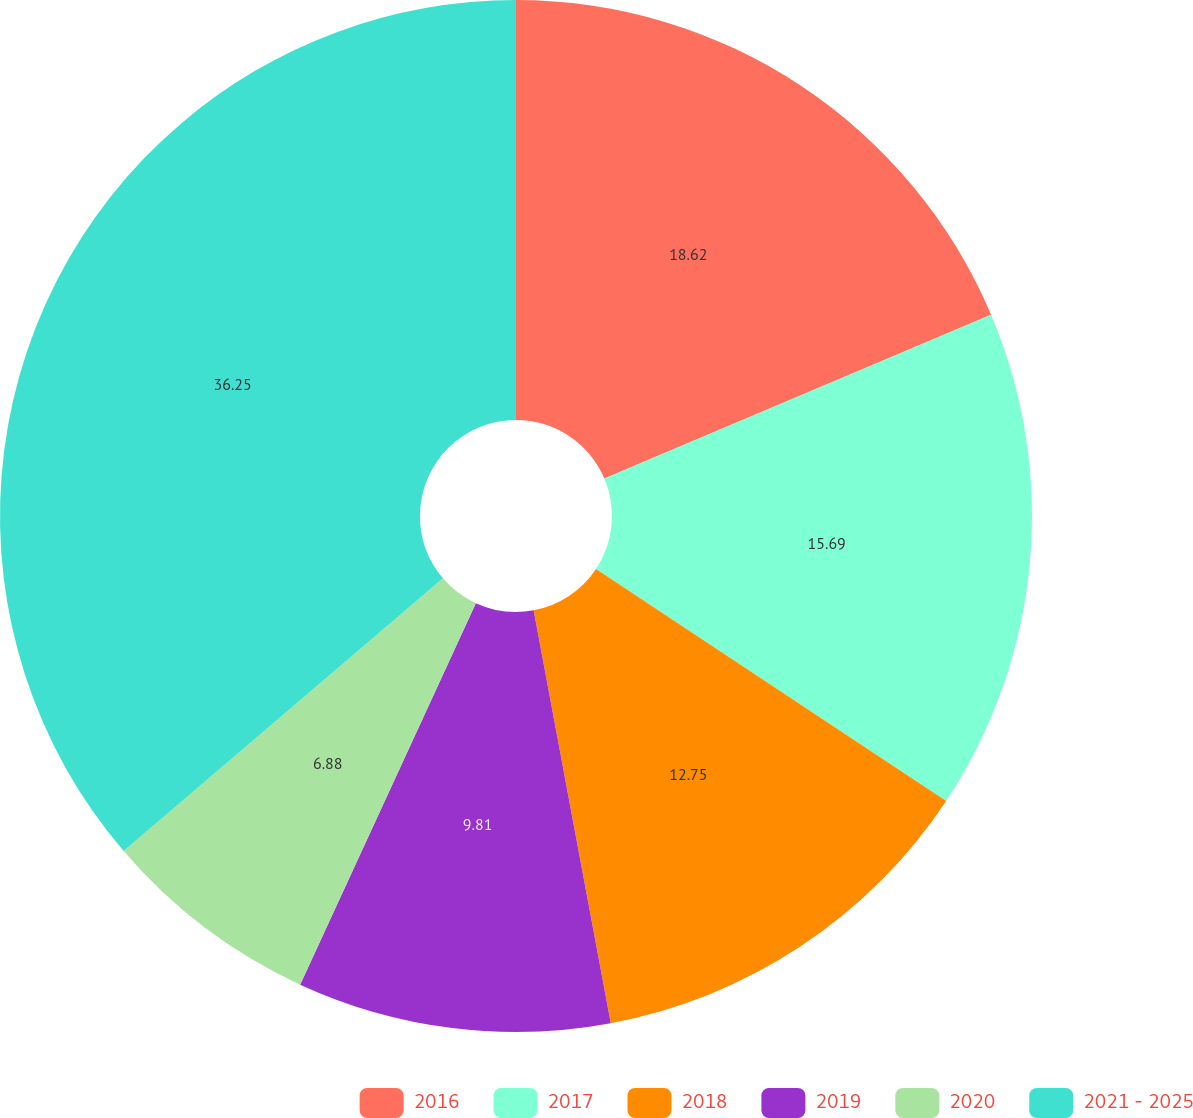Convert chart to OTSL. <chart><loc_0><loc_0><loc_500><loc_500><pie_chart><fcel>2016<fcel>2017<fcel>2018<fcel>2019<fcel>2020<fcel>2021 - 2025<nl><fcel>18.62%<fcel>15.69%<fcel>12.75%<fcel>9.81%<fcel>6.88%<fcel>36.25%<nl></chart> 